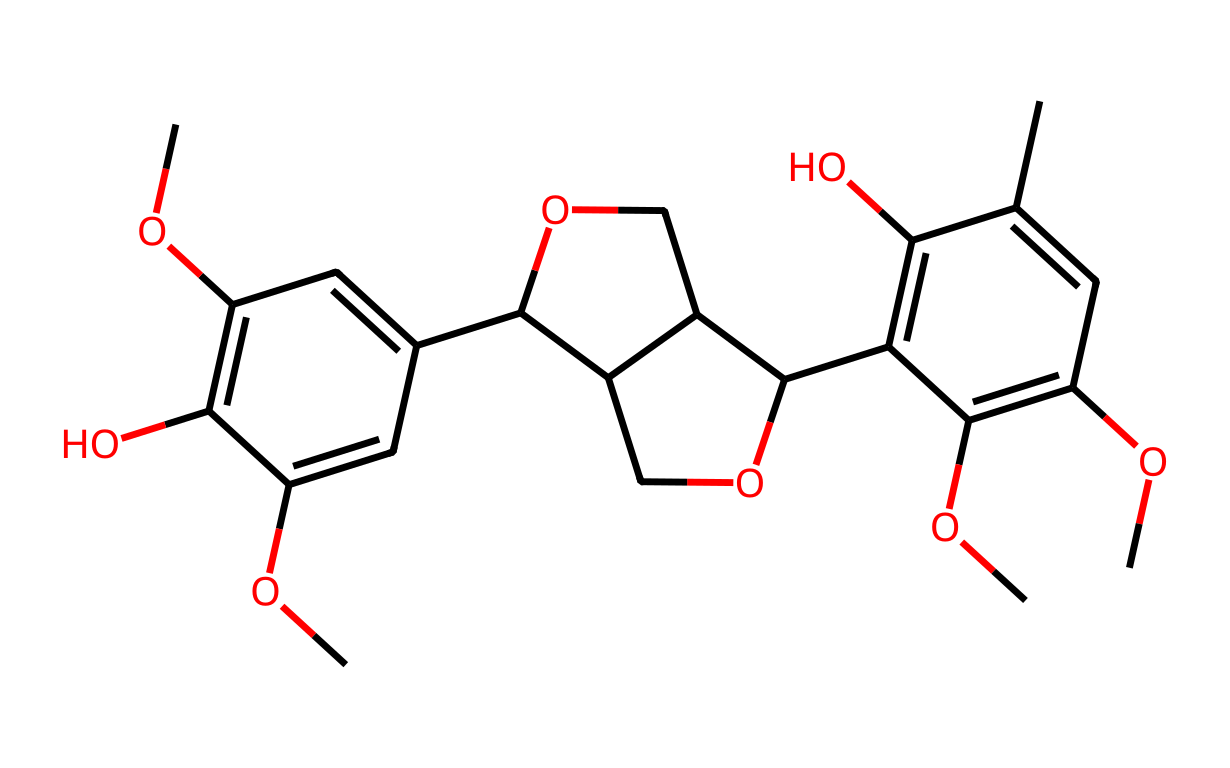What is the total number of carbon atoms in the molecule? To determine the number of carbon atoms, count each carbon atom represented in the SMILES structure. The structure represents a complex aromatic polymer indicating multiple phenolic units, leading to a total count of 21 carbon atoms.
Answer: 21 How many oxygen atoms are present in the compound? Oxygen atoms can be identified by counting the 'O's in the SMILES representation. Upon reviewing the structure, we find a total of 7 oxygen atoms.
Answer: 7 Is the molecular structure cyclic or acyclic? By analyzing the SMILES, we can see the presence of ring structures as indicated by the 'C' atoms being part of cycles (numbering indicates bonds forming rings). Since the molecule contains multiple linked cycles, it is indeed cyclic.
Answer: cyclic What type of functional groups are present in this compound? The chemical has methoxy (-OCH3) groups connected to the aromatic rings, as seen in the multiple 'OC' portions of the SMILES. The hydroxyl (-OH) groups are also visible. Therefore, the principal functional groups are methoxy and hydroxyl.
Answer: methoxy and hydroxyl What is the primary structural feature that identifies this molecule as lignin? The presence of an extensive network of interconnected aromatic rings and varied functional groups (like methoxy and hydroxyl) forms a complex polymer structure typical of lignin. This branching and connectivity pattern indicates that it is lignin.
Answer: interconnected aromatic rings How many rings are present in the structure? To ascertain the number of rings, we can examine the bonded structure and count distinct cycles formed. The SMILES showcases three major aromatic ring systems, leading to a total of 3 rings in the molecule.
Answer: 3 What does the presence of multiple methoxy groups suggest about the chemical's properties? Methoxy groups increase the lipophilicity and may influence the solubility of the molecule in organic solvents, which is characteristic of lignin compounds. The presence of methoxy groups suggests it may be less polar and potentially influence environmental interactions.
Answer: increased lipophilicity 